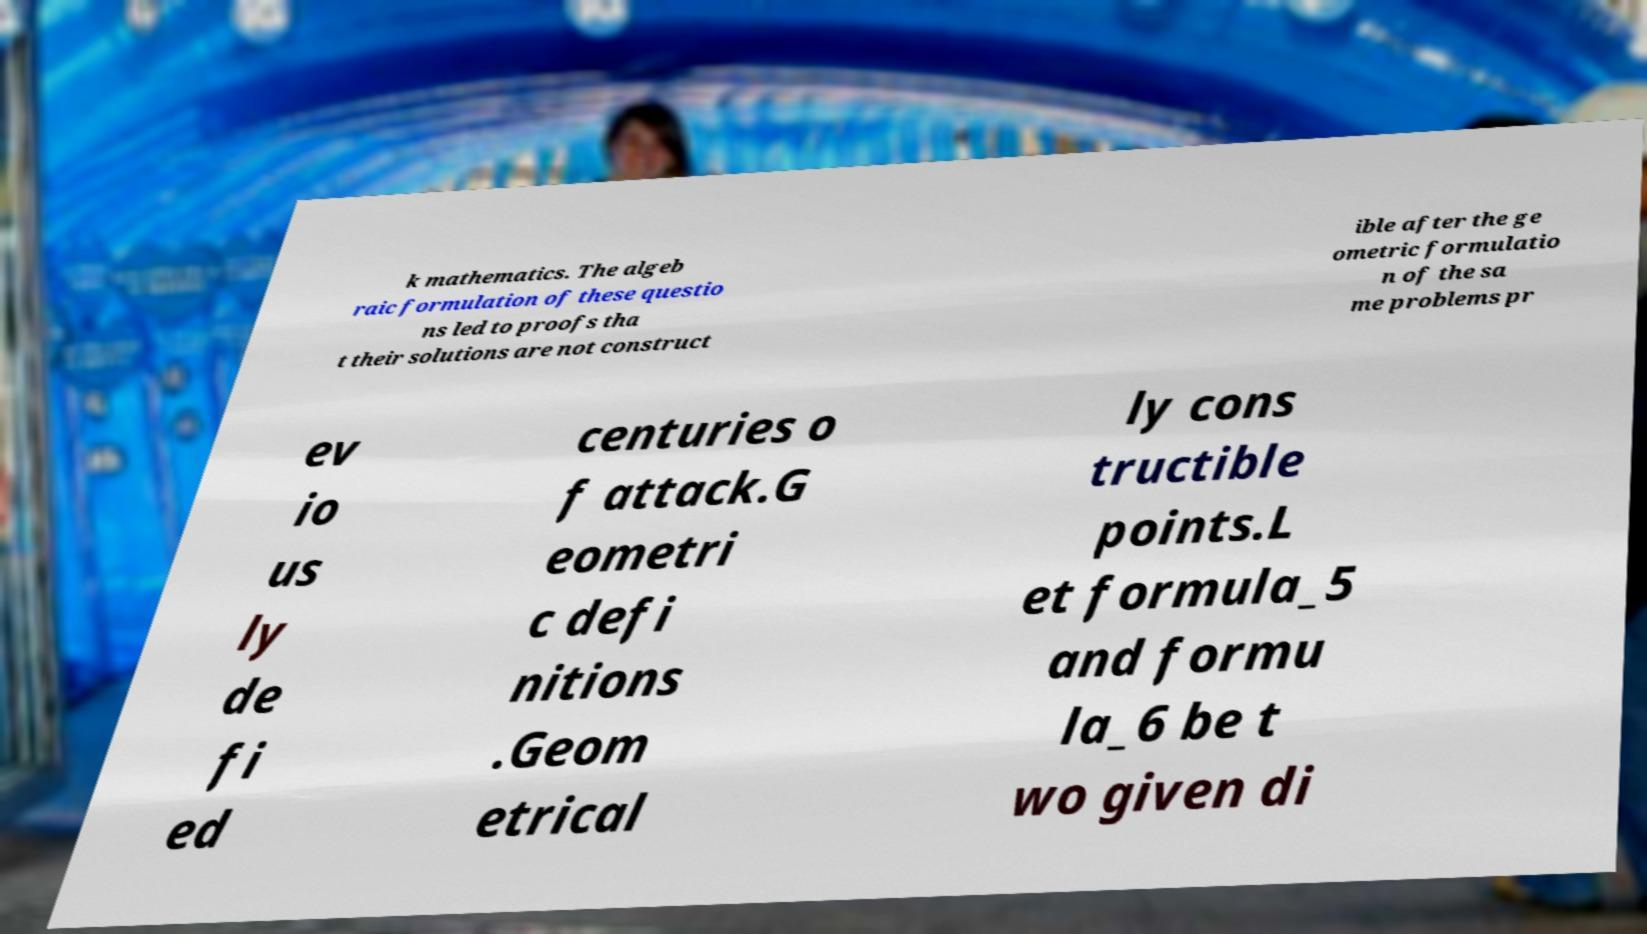Can you read and provide the text displayed in the image?This photo seems to have some interesting text. Can you extract and type it out for me? k mathematics. The algeb raic formulation of these questio ns led to proofs tha t their solutions are not construct ible after the ge ometric formulatio n of the sa me problems pr ev io us ly de fi ed centuries o f attack.G eometri c defi nitions .Geom etrical ly cons tructible points.L et formula_5 and formu la_6 be t wo given di 